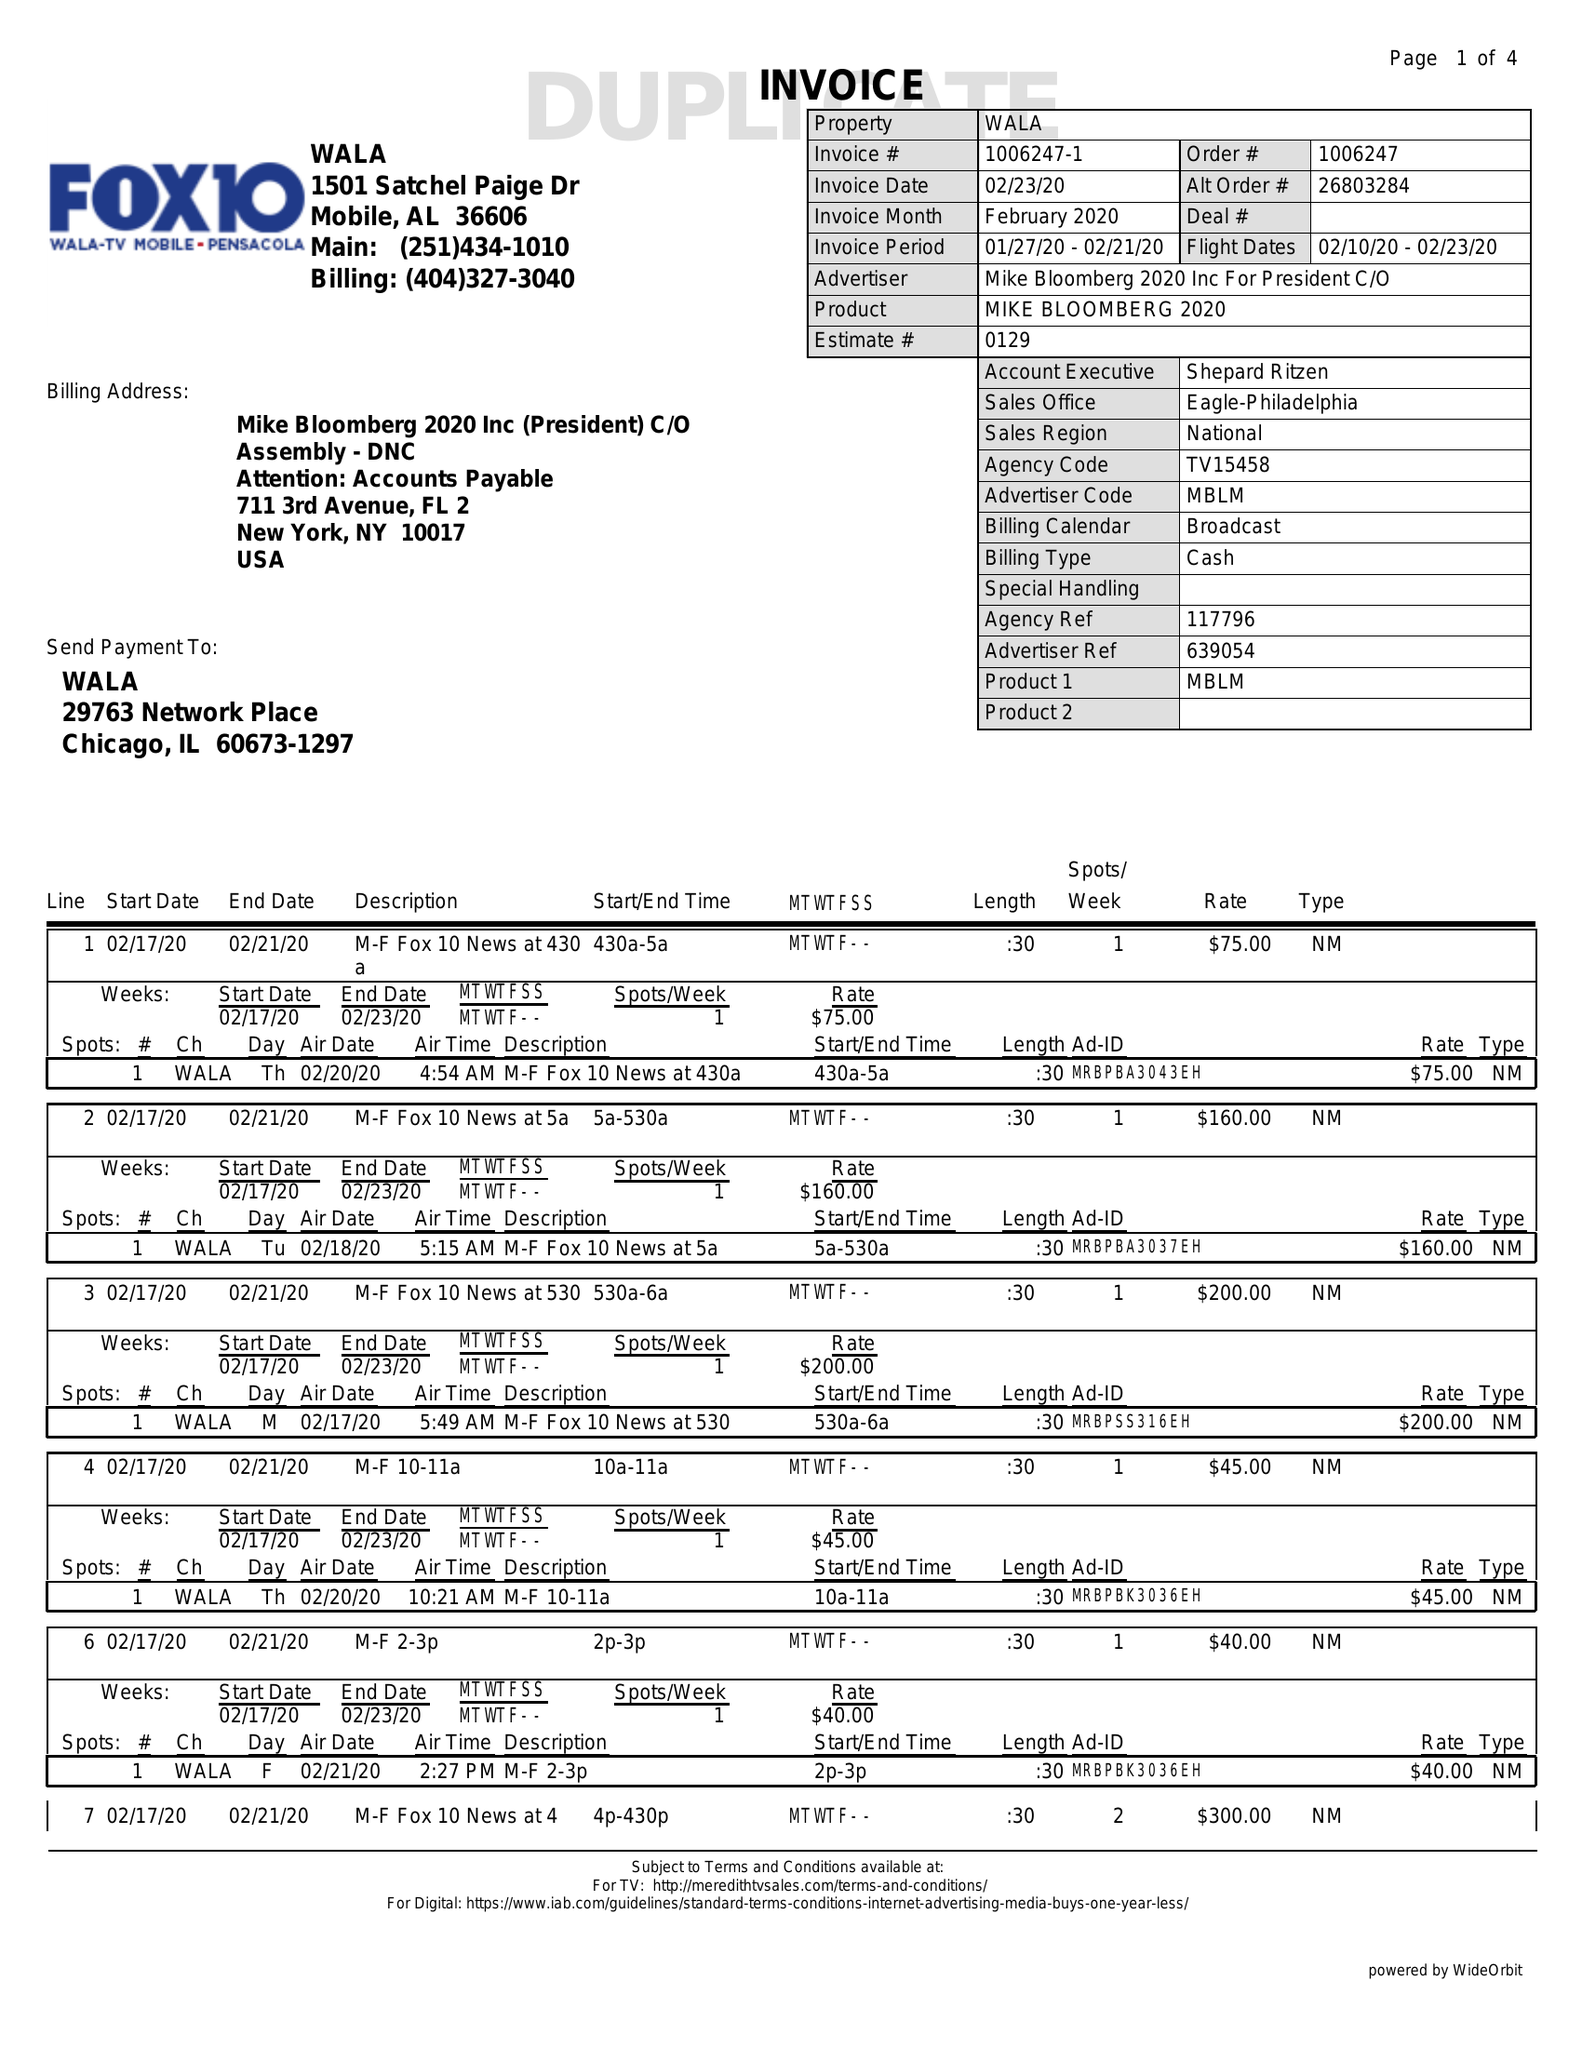What is the value for the advertiser?
Answer the question using a single word or phrase. MIKEBLOOMBERG2020INCFORPRESIDENTC/O 